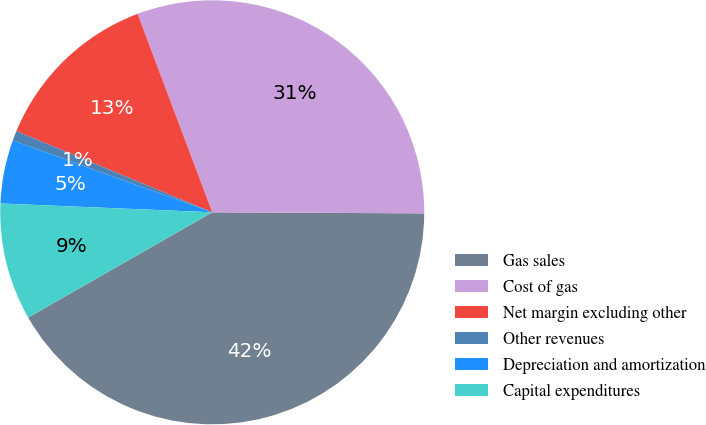Convert chart to OTSL. <chart><loc_0><loc_0><loc_500><loc_500><pie_chart><fcel>Gas sales<fcel>Cost of gas<fcel>Net margin excluding other<fcel>Other revenues<fcel>Depreciation and amortization<fcel>Capital expenditures<nl><fcel>41.66%<fcel>30.81%<fcel>13.02%<fcel>0.75%<fcel>4.84%<fcel>8.93%<nl></chart> 